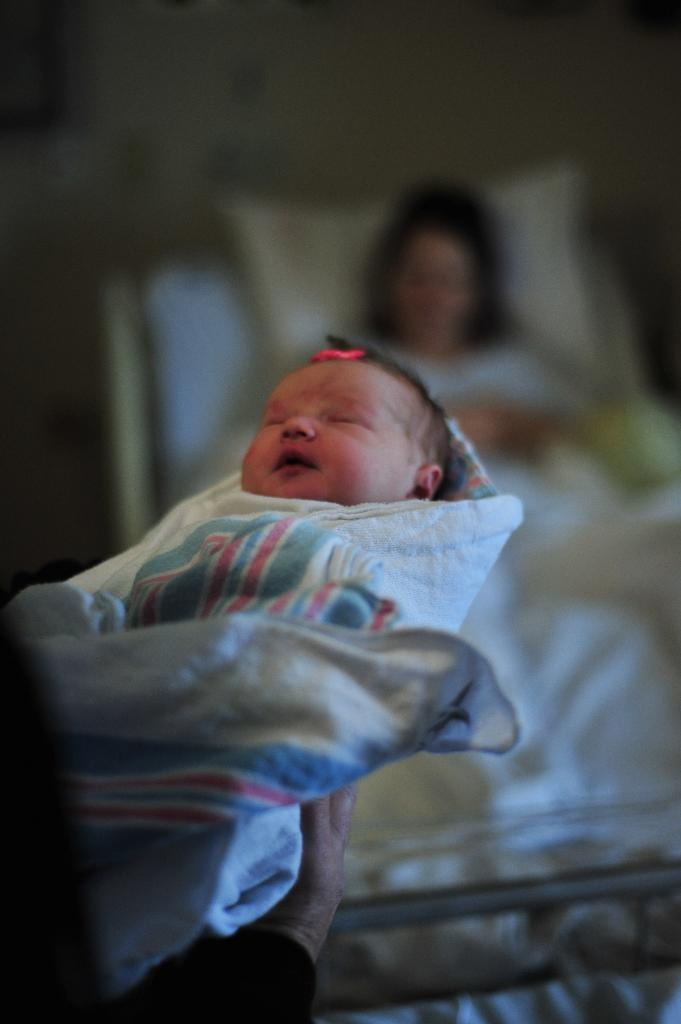What is the main subject of the image? The main subject of the image is a person holding a baby. Can you describe the secondary subject in the image? In the background of the image, there is a lady sleeping on a bed. What type of road can be seen in the image? There is no road visible in the image; it features a person holding a baby and a lady sleeping on a bed. Are there any fairies present in the image? There are no fairies present in the image. 